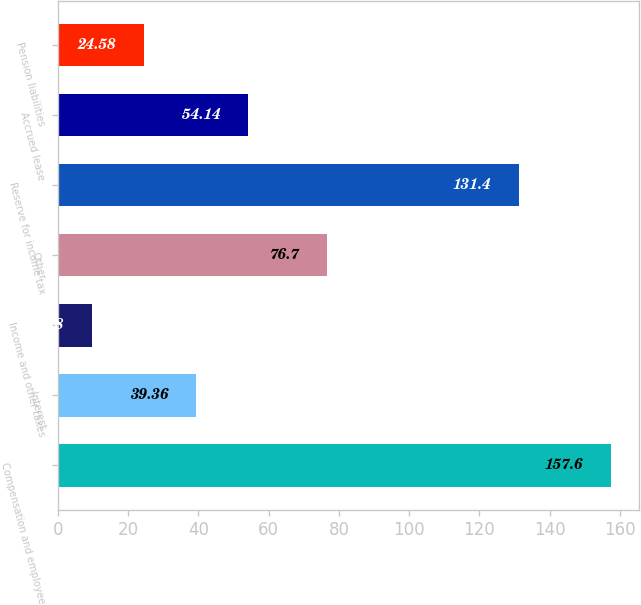Convert chart. <chart><loc_0><loc_0><loc_500><loc_500><bar_chart><fcel>Compensation and employee<fcel>Interest<fcel>Income and other taxes<fcel>Other<fcel>Reserve for income tax<fcel>Accrued lease<fcel>Pension liabilities<nl><fcel>157.6<fcel>39.36<fcel>9.8<fcel>76.7<fcel>131.4<fcel>54.14<fcel>24.58<nl></chart> 